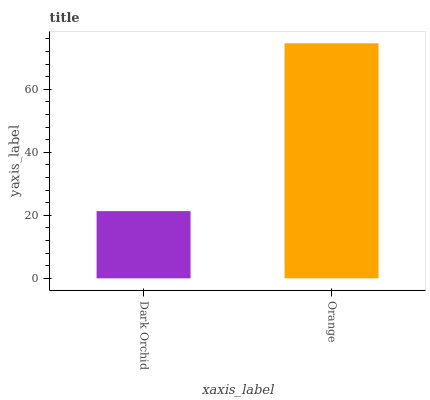Is Dark Orchid the minimum?
Answer yes or no. Yes. Is Orange the maximum?
Answer yes or no. Yes. Is Orange the minimum?
Answer yes or no. No. Is Orange greater than Dark Orchid?
Answer yes or no. Yes. Is Dark Orchid less than Orange?
Answer yes or no. Yes. Is Dark Orchid greater than Orange?
Answer yes or no. No. Is Orange less than Dark Orchid?
Answer yes or no. No. Is Orange the high median?
Answer yes or no. Yes. Is Dark Orchid the low median?
Answer yes or no. Yes. Is Dark Orchid the high median?
Answer yes or no. No. Is Orange the low median?
Answer yes or no. No. 